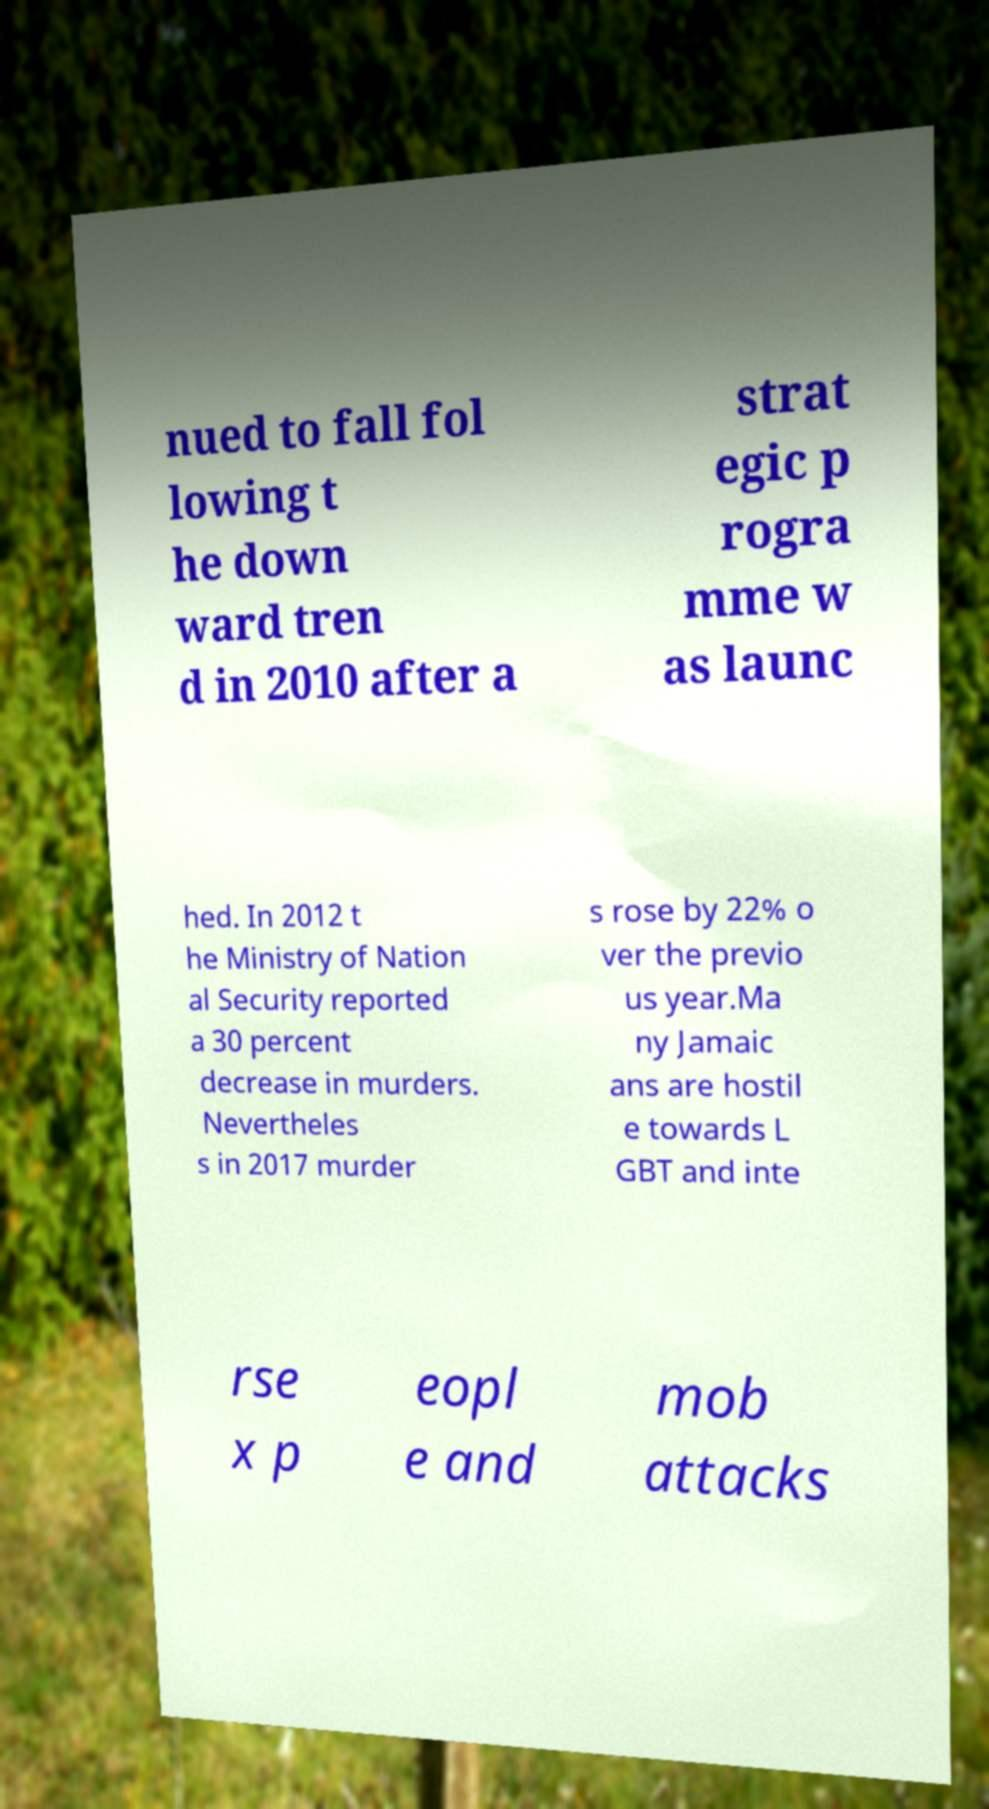Can you read and provide the text displayed in the image?This photo seems to have some interesting text. Can you extract and type it out for me? nued to fall fol lowing t he down ward tren d in 2010 after a strat egic p rogra mme w as launc hed. In 2012 t he Ministry of Nation al Security reported a 30 percent decrease in murders. Nevertheles s in 2017 murder s rose by 22% o ver the previo us year.Ma ny Jamaic ans are hostil e towards L GBT and inte rse x p eopl e and mob attacks 